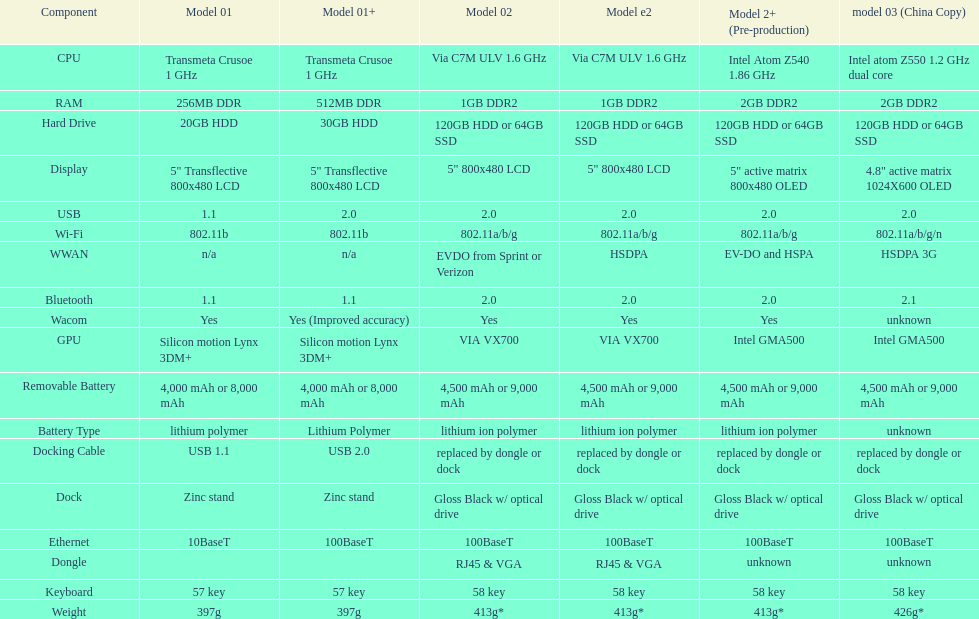6ghz processing speed? 2. 